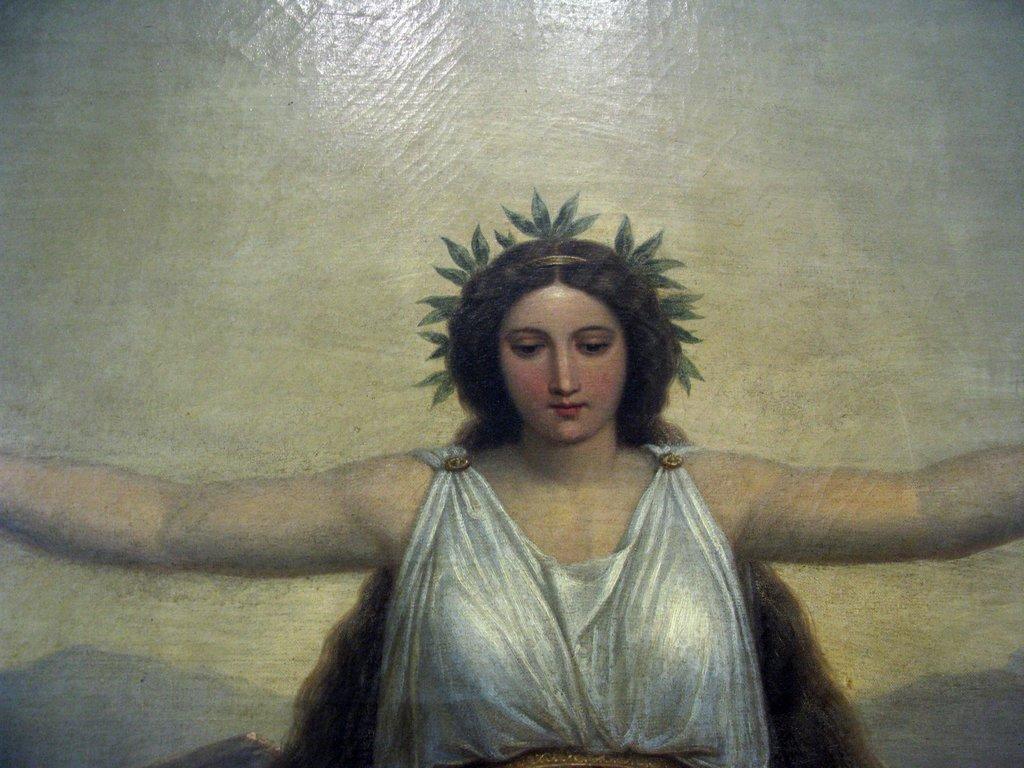Please provide a concise description of this image. In this image we can see a painting of a woman who is wearing white color dress. 